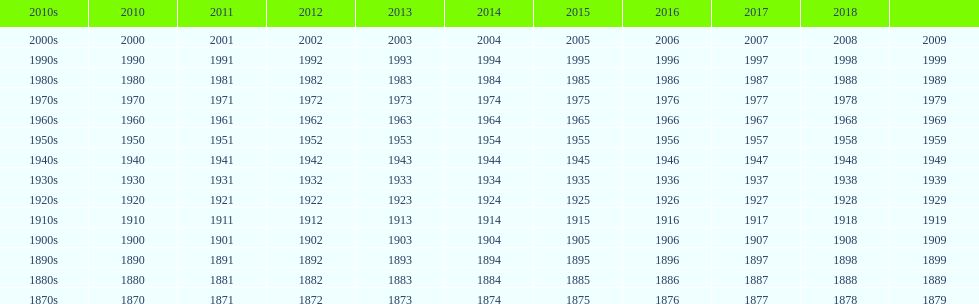Which decade stands out by having a smaller number of years in its row compared to the rest? 2010s. 